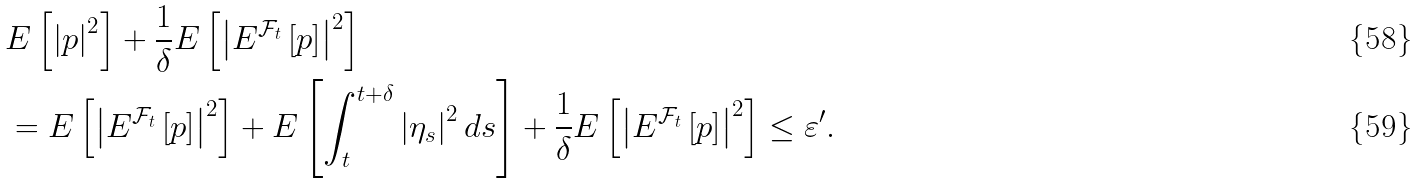Convert formula to latex. <formula><loc_0><loc_0><loc_500><loc_500>& E \left [ \left | p \right | ^ { 2 } \right ] + \frac { 1 } { \delta } E \left [ \left | E ^ { \mathcal { F } _ { t } } \left [ p \right ] \right | ^ { 2 } \right ] \\ & = E \left [ \left | E ^ { \mathcal { F } _ { t } } \left [ p \right ] \right | ^ { 2 } \right ] + E \left [ \int _ { t } ^ { t + \delta } \left | \eta _ { s } \right | ^ { 2 } d s \right ] + \frac { 1 } { \delta } E \left [ \left | E ^ { \mathcal { F } _ { t } } \left [ p \right ] \right | ^ { 2 } \right ] \leq \varepsilon ^ { \prime } .</formula> 